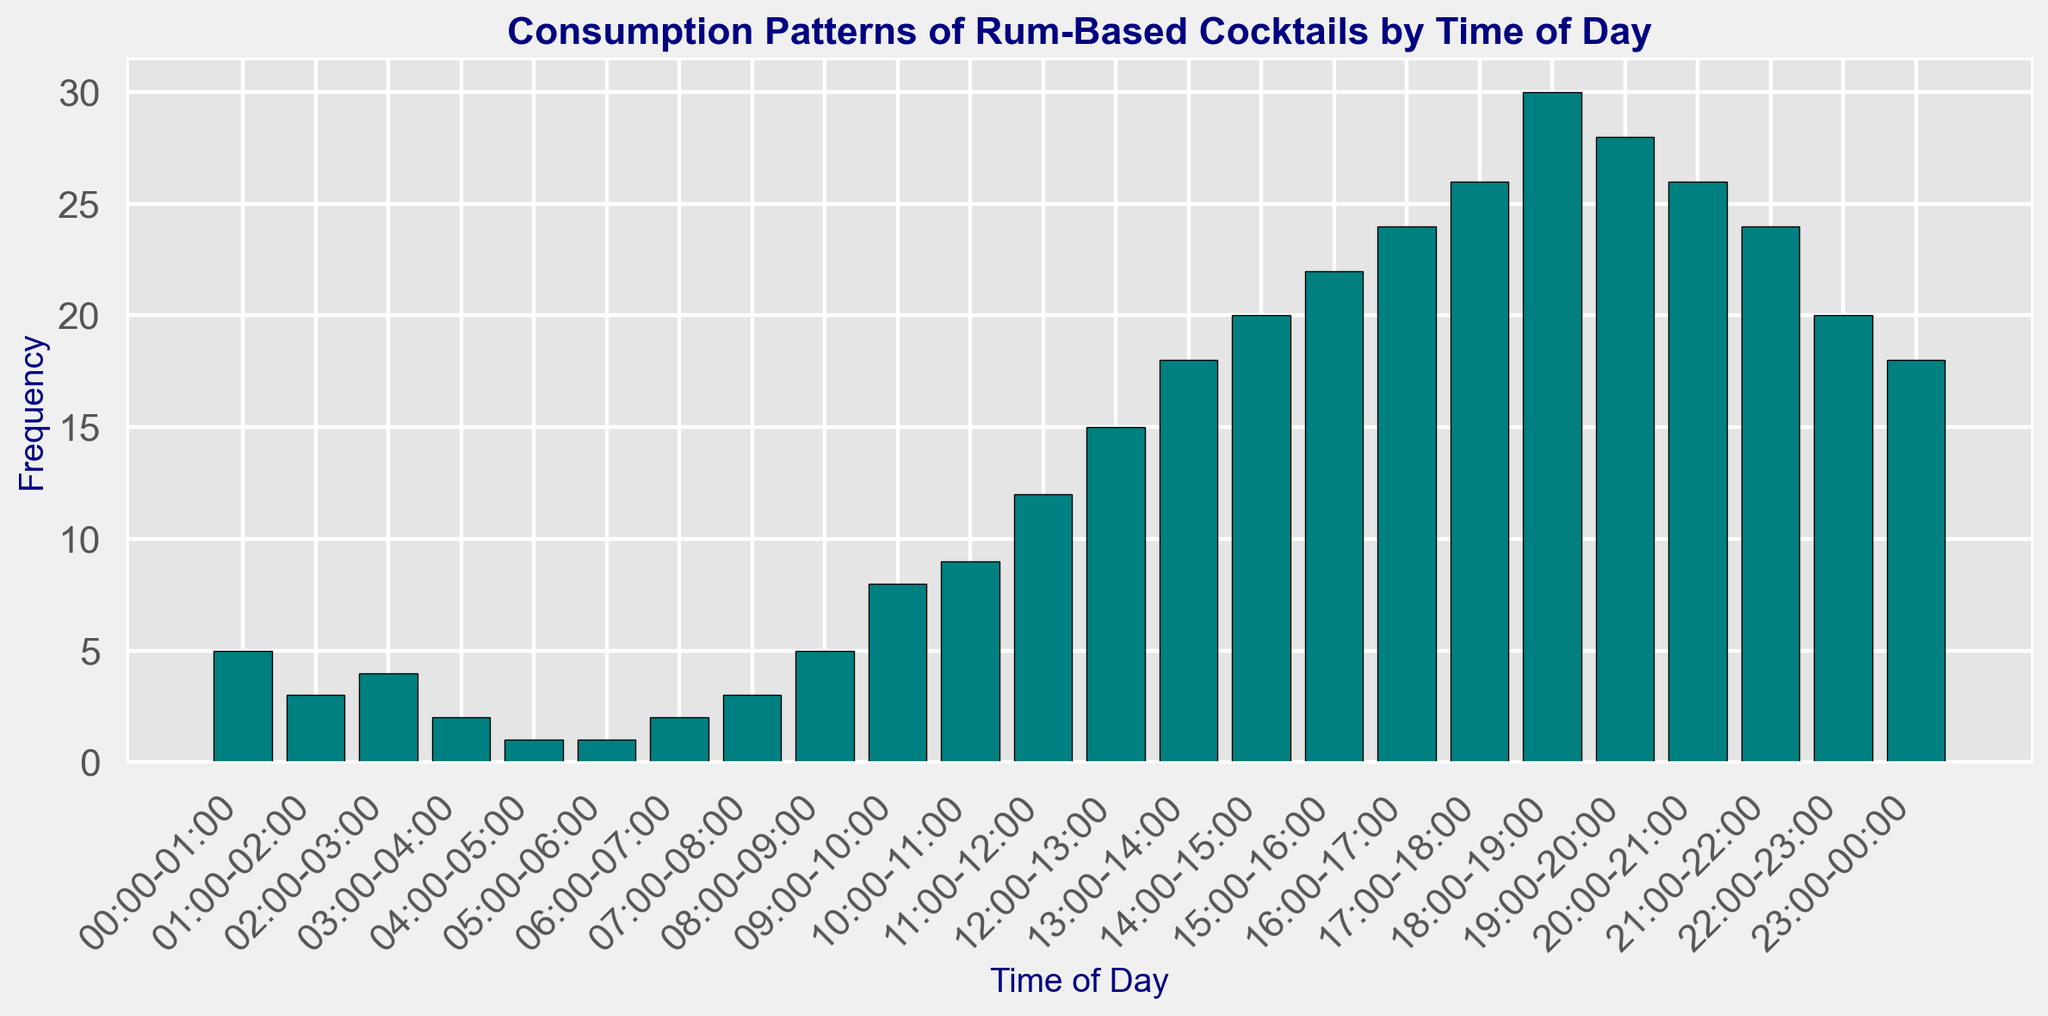What time of day sees the highest consumption of rum-based cocktails? The highest bar in the histogram indicates the time with the highest frequency. The tallest bar corresponds to the time interval 18:00-19:00.
Answer: 18:00-19:00 How does the consumption frequency at 12:00-13:00 compare to 23:00-00:00? Check the height of the bars for both time intervals. The bar at 12:00-13:00 is taller than the one at 23:00-00:00, indicating higher consumption frequency.
Answer: 12:00-13:00 is higher What is the total consumption frequency from 15:00 to 18:00? Sum the frequencies from 15:00-16:00, 16:00-17:00, 17:00-18:00. The bars show frequencies 22, 24, 26 respectively. 22 + 24 + 26 = 72.
Answer: 72 During which time interval is the decrease in consumption most noticeable? Identify the largest drop in bar height between two consecutive intervals. The most noticeable decrease is between 19:00-20:00 (30) to 20:00-21:00 (26).
Answer: 19:00-20:00 to 20:00-21:00 What's the total consumption frequency in the AM (00:00 - 12:00)? Sum the frequencies for intervals from 00:00-01:00 to 11:00-12:00, i.e., 5 + 3 + 4 + 2 + 1 + 1 + 2 + 3 + 5 + 8 + 9 + 12 = 55.
Answer: 55 Which two consecutive time intervals in the morning (00:00 - 12:00) have the smallest change in consumption frequency? Compare the differences in frequency between each pair of consecutive intervals in the morning. The smallest change is between 02:00-03:00 (4) and 03:00-04:00 (2), with a change of 2.
Answer: 02:00-03:00 to 03:00-04:00 How many intervals have a frequency of 20 or more? Count how many bars reach a height of 20 or more. The intervals are 14:00-15:00 (20), 15:00-16:00 (22), 16:00-17:00 (24), 17:00-18:00 (26), 18:00-19:00 (30), 19:00-20:00 (28), 20:00-21:00 (26), 21:00-22:00 (24), and 22:00-23:00 (20). This totals 9 intervals.
Answer: 9 What is the average consumption frequency during the afternoon hours (12:00 - 18:00)? Calculate the average of frequencies from 12:00-13:00, 13:00-14:00, 14:00-15:00, 15:00-16:00, 16:00-17:00, and 17:00-18:00. The total sum of these frequencies is 15 + 18 + 20 + 22 + 24 + 26 = 125. Divide by the number of intervals (6). 125 / 6 = 20.83.
Answer: 20.83 